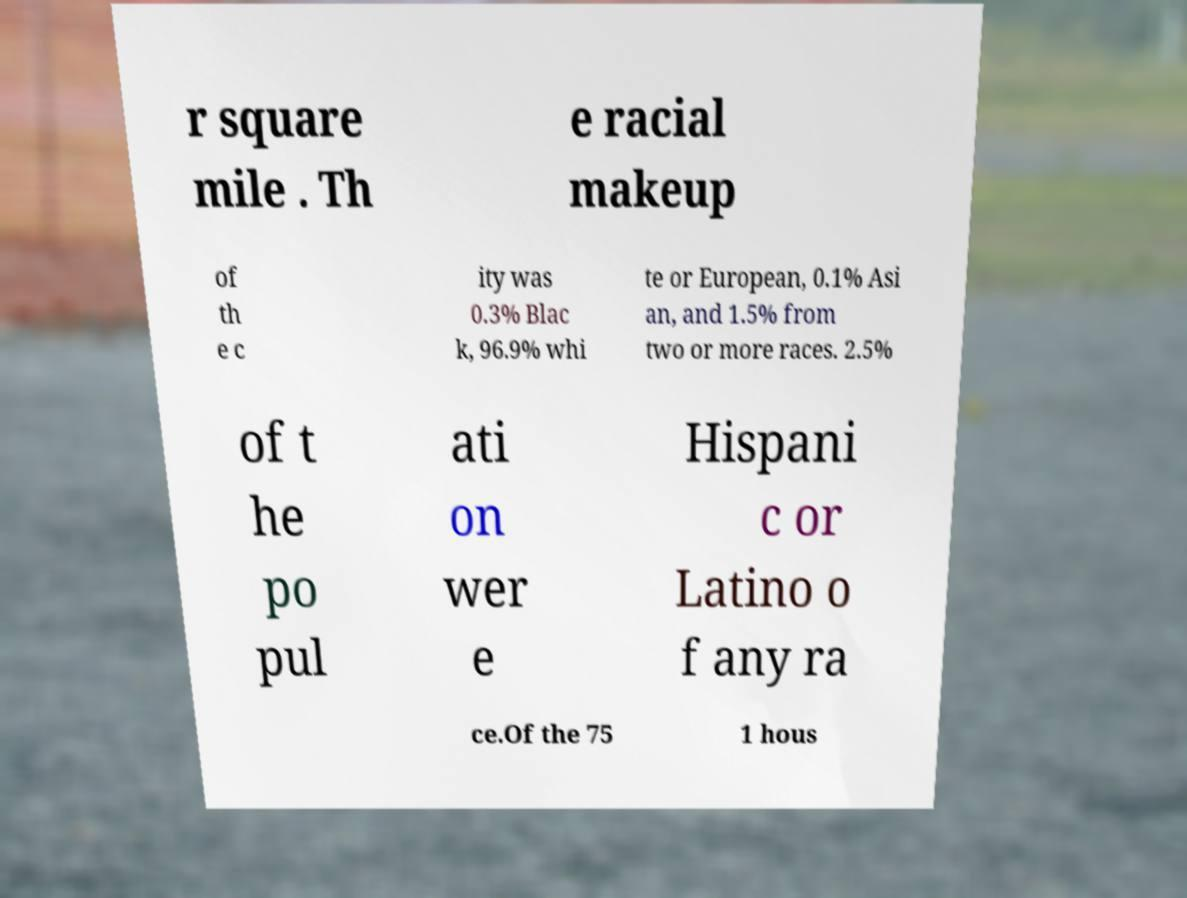Please identify and transcribe the text found in this image. r square mile . Th e racial makeup of th e c ity was 0.3% Blac k, 96.9% whi te or European, 0.1% Asi an, and 1.5% from two or more races. 2.5% of t he po pul ati on wer e Hispani c or Latino o f any ra ce.Of the 75 1 hous 